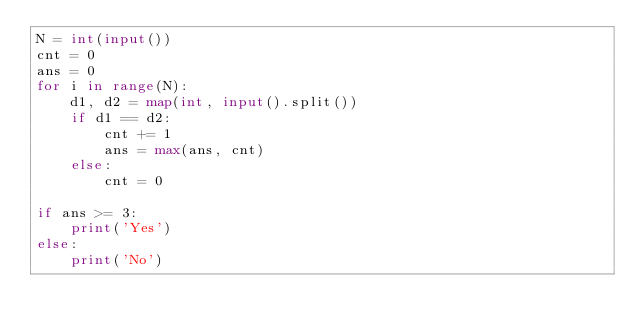<code> <loc_0><loc_0><loc_500><loc_500><_Python_>N = int(input())
cnt = 0
ans = 0
for i in range(N):
    d1, d2 = map(int, input().split())
    if d1 == d2:
        cnt += 1
        ans = max(ans, cnt)
    else:
        cnt = 0

if ans >= 3:
    print('Yes')
else:
    print('No')
</code> 